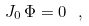<formula> <loc_0><loc_0><loc_500><loc_500>J _ { 0 } \, \Phi = 0 \ ,</formula> 